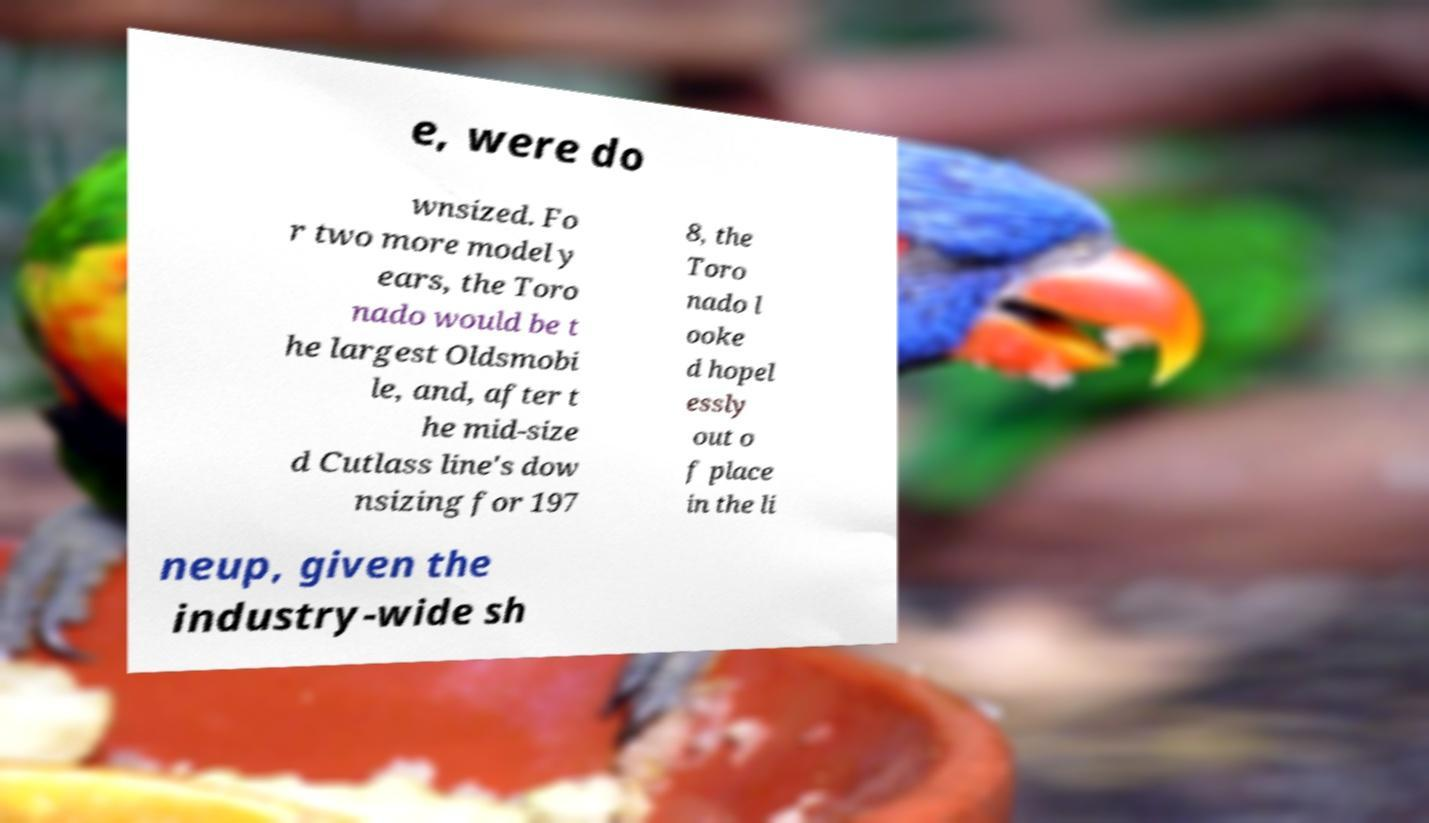I need the written content from this picture converted into text. Can you do that? e, were do wnsized. Fo r two more model y ears, the Toro nado would be t he largest Oldsmobi le, and, after t he mid-size d Cutlass line's dow nsizing for 197 8, the Toro nado l ooke d hopel essly out o f place in the li neup, given the industry-wide sh 